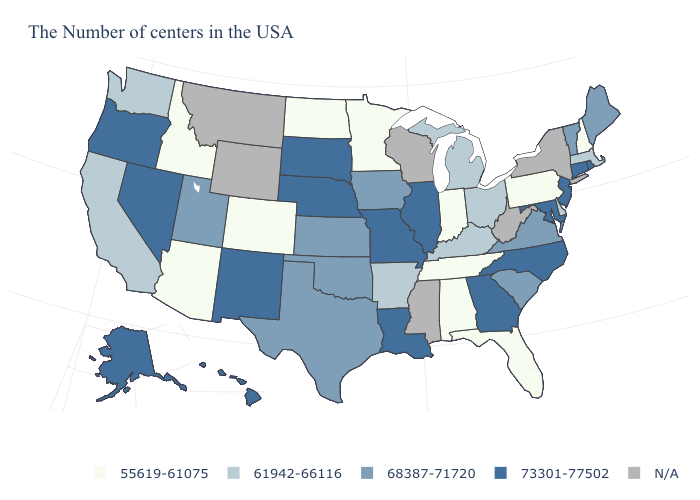Does New Hampshire have the lowest value in the Northeast?
Write a very short answer. Yes. What is the value of California?
Write a very short answer. 61942-66116. What is the highest value in the USA?
Short answer required. 73301-77502. Among the states that border Nebraska , does Missouri have the highest value?
Keep it brief. Yes. Does South Dakota have the highest value in the MidWest?
Short answer required. Yes. What is the value of Alaska?
Short answer required. 73301-77502. Name the states that have a value in the range N/A?
Short answer required. New York, West Virginia, Wisconsin, Mississippi, Wyoming, Montana. Does Georgia have the highest value in the South?
Short answer required. Yes. Does Colorado have the highest value in the West?
Concise answer only. No. Which states have the lowest value in the South?
Keep it brief. Florida, Alabama, Tennessee. What is the lowest value in states that border New Jersey?
Keep it brief. 55619-61075. Which states have the lowest value in the USA?
Be succinct. New Hampshire, Pennsylvania, Florida, Indiana, Alabama, Tennessee, Minnesota, North Dakota, Colorado, Arizona, Idaho. Name the states that have a value in the range 61942-66116?
Short answer required. Massachusetts, Delaware, Ohio, Michigan, Kentucky, Arkansas, California, Washington. Does New Hampshire have the highest value in the USA?
Write a very short answer. No. 